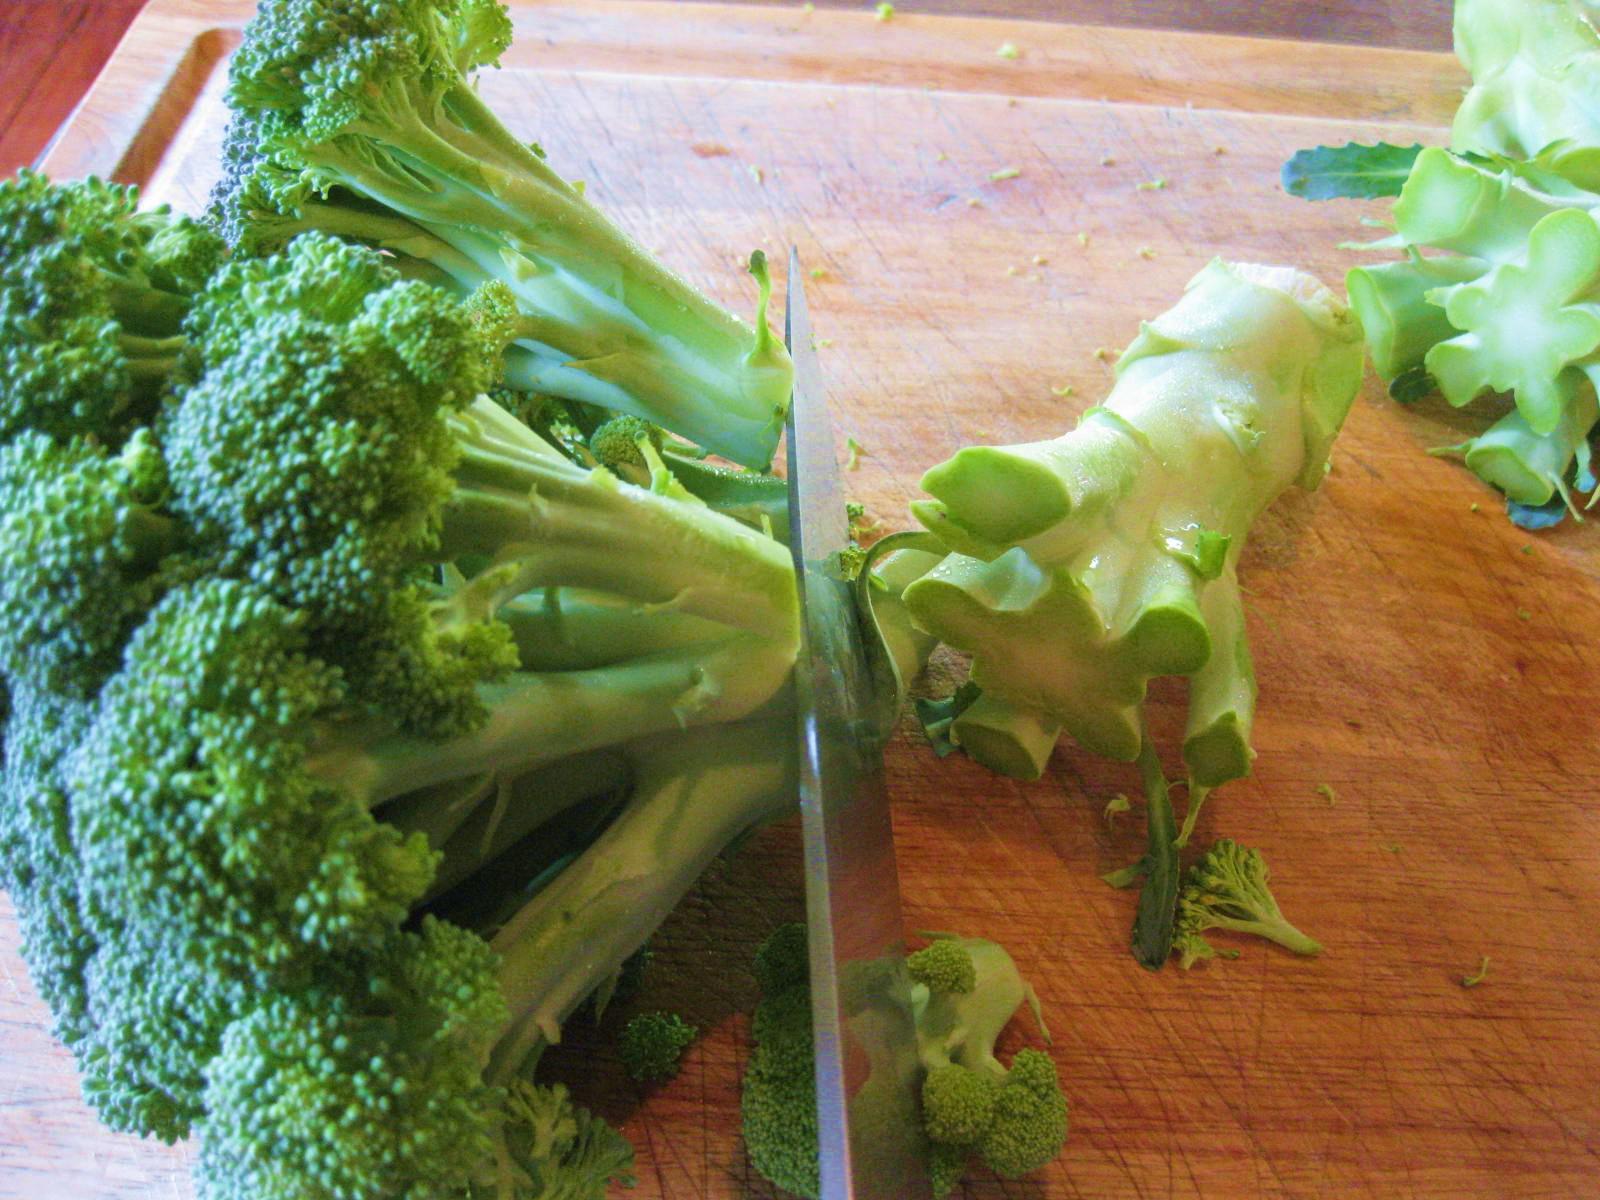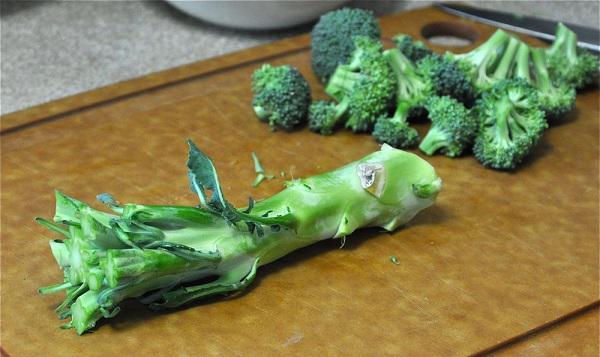The first image is the image on the left, the second image is the image on the right. Considering the images on both sides, is "There is fresh broccoli in a field." valid? Answer yes or no. No. The first image is the image on the left, the second image is the image on the right. Analyze the images presented: Is the assertion "In at least one image there is a total of one head of broccoli still growing on a stalk." valid? Answer yes or no. No. 